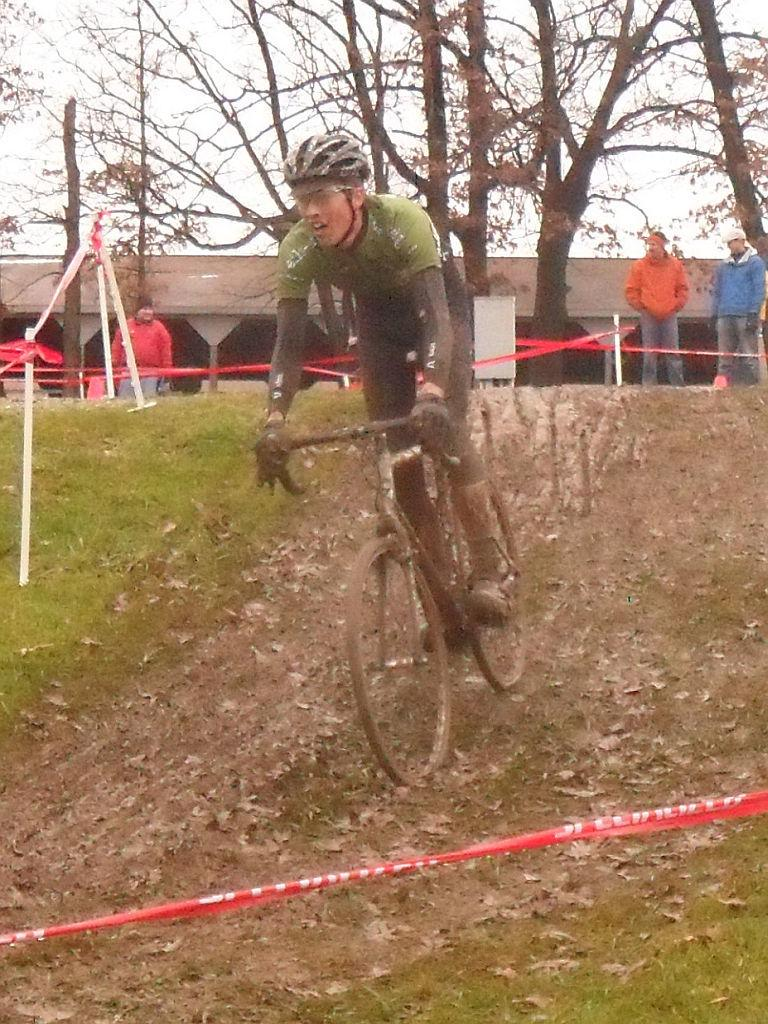What is the main subject of the image? There is a man riding a bicycle in the image. Can you describe the background of the image? There are 3 people, trees, a building, and the sky visible in the background of the image. How many people are present in the image? There is one man riding a bicycle and 3 people in the background, making a total of 4 people in the image. What type of iron can be seen hanging from the trees in the image? There is no iron visible in the image, nor are there any hanging from the trees. 